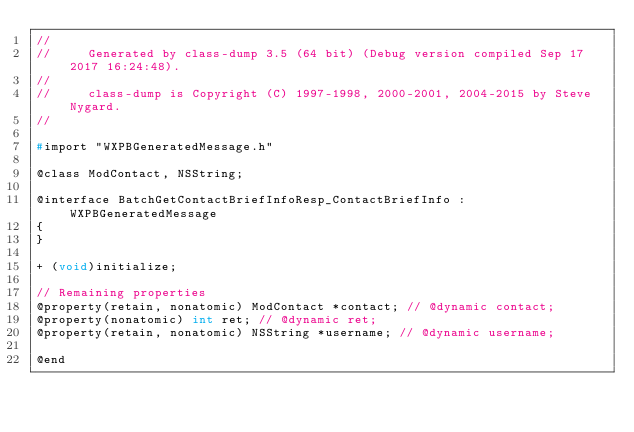<code> <loc_0><loc_0><loc_500><loc_500><_C_>//
//     Generated by class-dump 3.5 (64 bit) (Debug version compiled Sep 17 2017 16:24:48).
//
//     class-dump is Copyright (C) 1997-1998, 2000-2001, 2004-2015 by Steve Nygard.
//

#import "WXPBGeneratedMessage.h"

@class ModContact, NSString;

@interface BatchGetContactBriefInfoResp_ContactBriefInfo : WXPBGeneratedMessage
{
}

+ (void)initialize;

// Remaining properties
@property(retain, nonatomic) ModContact *contact; // @dynamic contact;
@property(nonatomic) int ret; // @dynamic ret;
@property(retain, nonatomic) NSString *username; // @dynamic username;

@end

</code> 